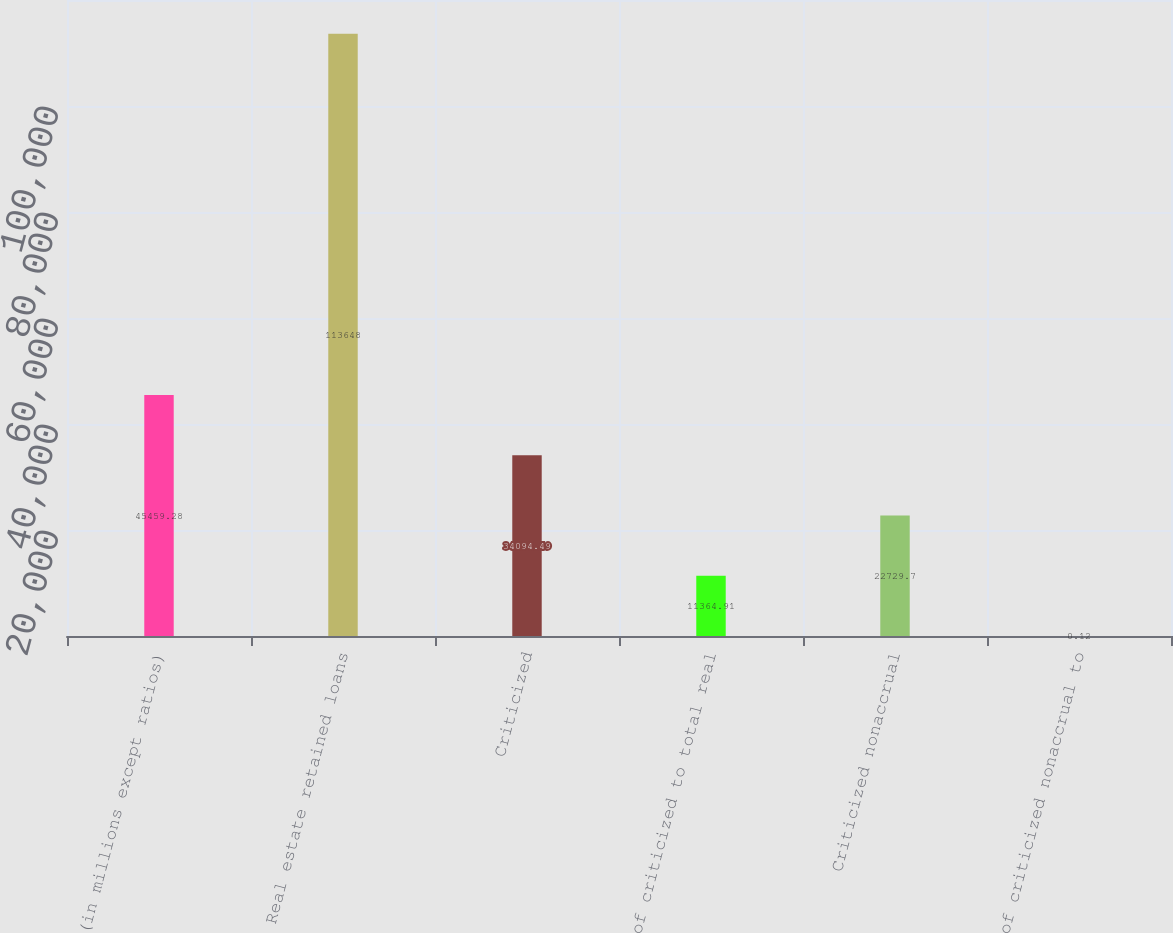Convert chart. <chart><loc_0><loc_0><loc_500><loc_500><bar_chart><fcel>(in millions except ratios)<fcel>Real estate retained loans<fcel>Criticized<fcel>of criticized to total real<fcel>Criticized nonaccrual<fcel>of criticized nonaccrual to<nl><fcel>45459.3<fcel>113648<fcel>34094.5<fcel>11364.9<fcel>22729.7<fcel>0.12<nl></chart> 